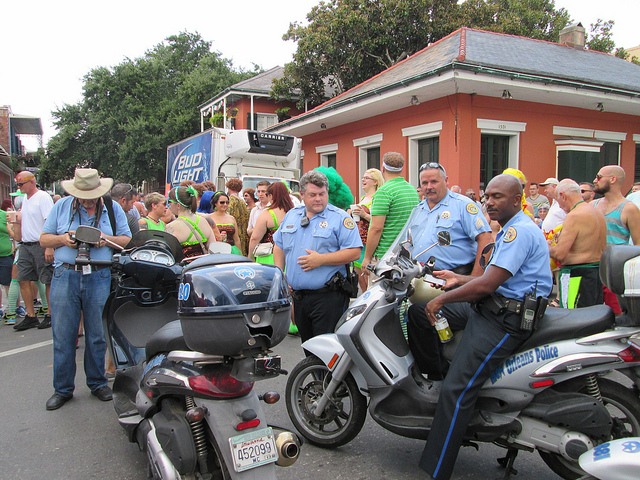Please extract the text content from this image. BUD 452099 LIGHT 381 Orleans 